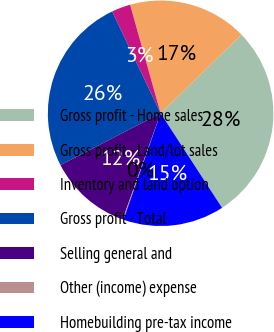Convert chart. <chart><loc_0><loc_0><loc_500><loc_500><pie_chart><fcel>Gross profit - Home sales<fcel>Gross profit - Land/lot sales<fcel>Inventory and land option<fcel>Gross profit - Total<fcel>Selling general and<fcel>Other (income) expense<fcel>Homebuilding pre-tax income<nl><fcel>28.11%<fcel>17.09%<fcel>2.71%<fcel>25.53%<fcel>11.93%<fcel>0.13%<fcel>14.51%<nl></chart> 